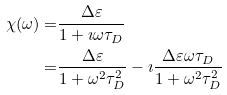Convert formula to latex. <formula><loc_0><loc_0><loc_500><loc_500>\chi ( \omega ) = & \frac { \Delta \varepsilon } { 1 + \imath \omega \tau _ { D } } \\ = & \frac { \Delta \varepsilon } { 1 + \omega ^ { 2 } \tau _ { D } ^ { 2 } } - \imath \frac { \Delta \varepsilon \omega \tau _ { D } } { 1 + \omega ^ { 2 } \tau _ { D } ^ { 2 } }</formula> 